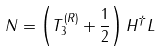Convert formula to latex. <formula><loc_0><loc_0><loc_500><loc_500>N = \left ( T _ { 3 } ^ { ( R ) } + \frac { 1 } { 2 } \right ) H ^ { \dagger } L</formula> 